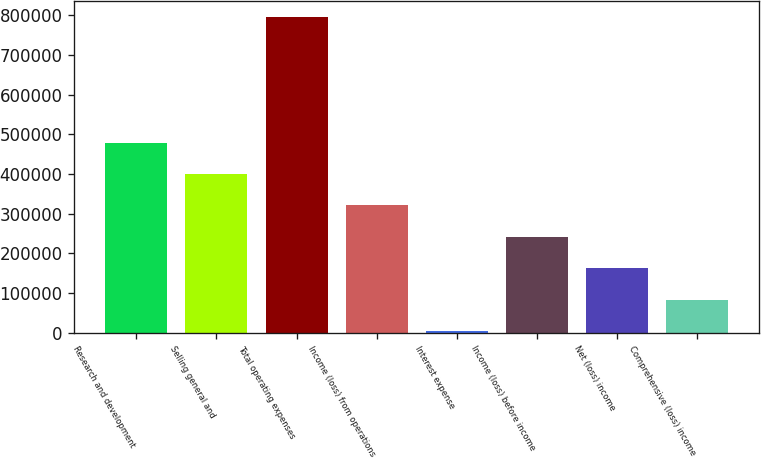Convert chart. <chart><loc_0><loc_0><loc_500><loc_500><bar_chart><fcel>Research and development<fcel>Selling general and<fcel>Total operating expenses<fcel>Income (loss) from operations<fcel>Interest expense<fcel>Income (loss) before income<fcel>Net (loss) income<fcel>Comprehensive (loss) income<nl><fcel>478906<fcel>399610<fcel>796090<fcel>320313<fcel>3129<fcel>241017<fcel>161721<fcel>82425.1<nl></chart> 